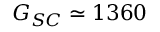<formula> <loc_0><loc_0><loc_500><loc_500>G _ { S C } \simeq 1 3 6 0</formula> 